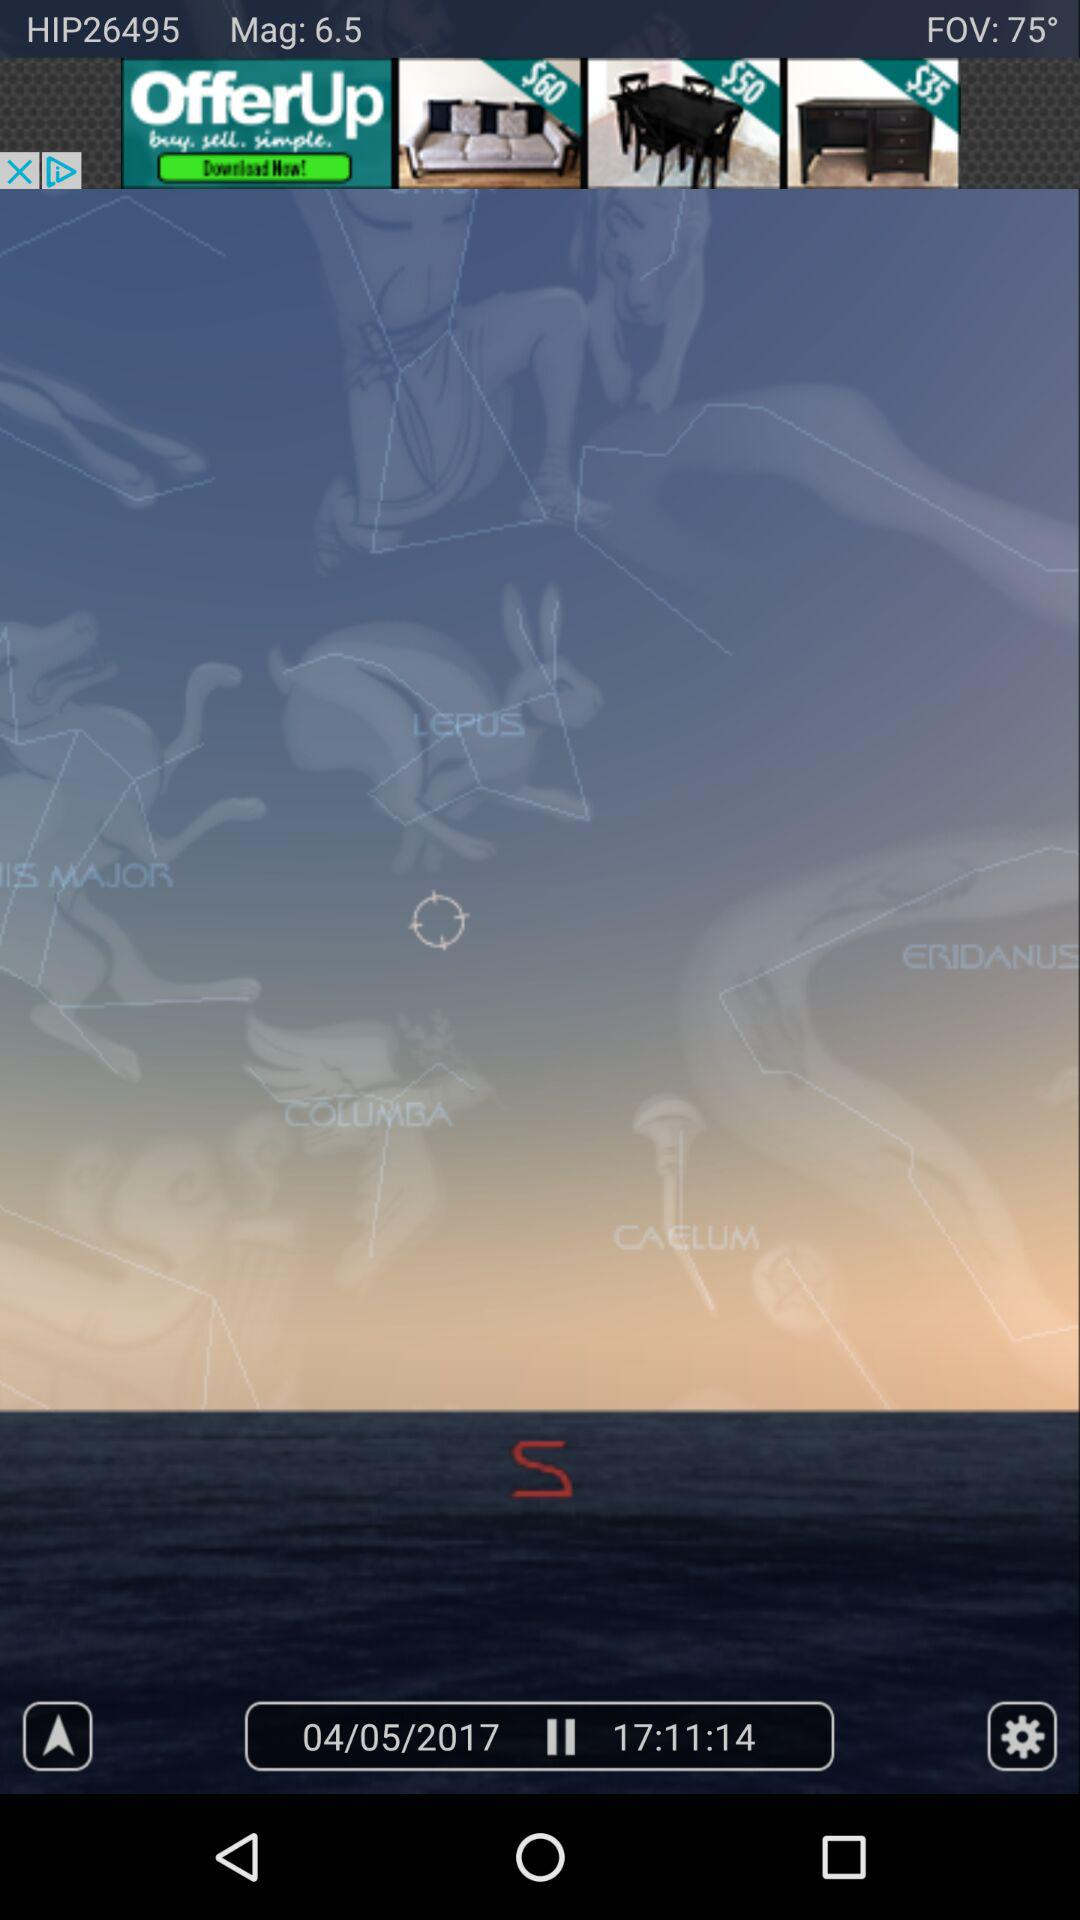What is the mentioned date? The mentioned date is April 5, 2017. 